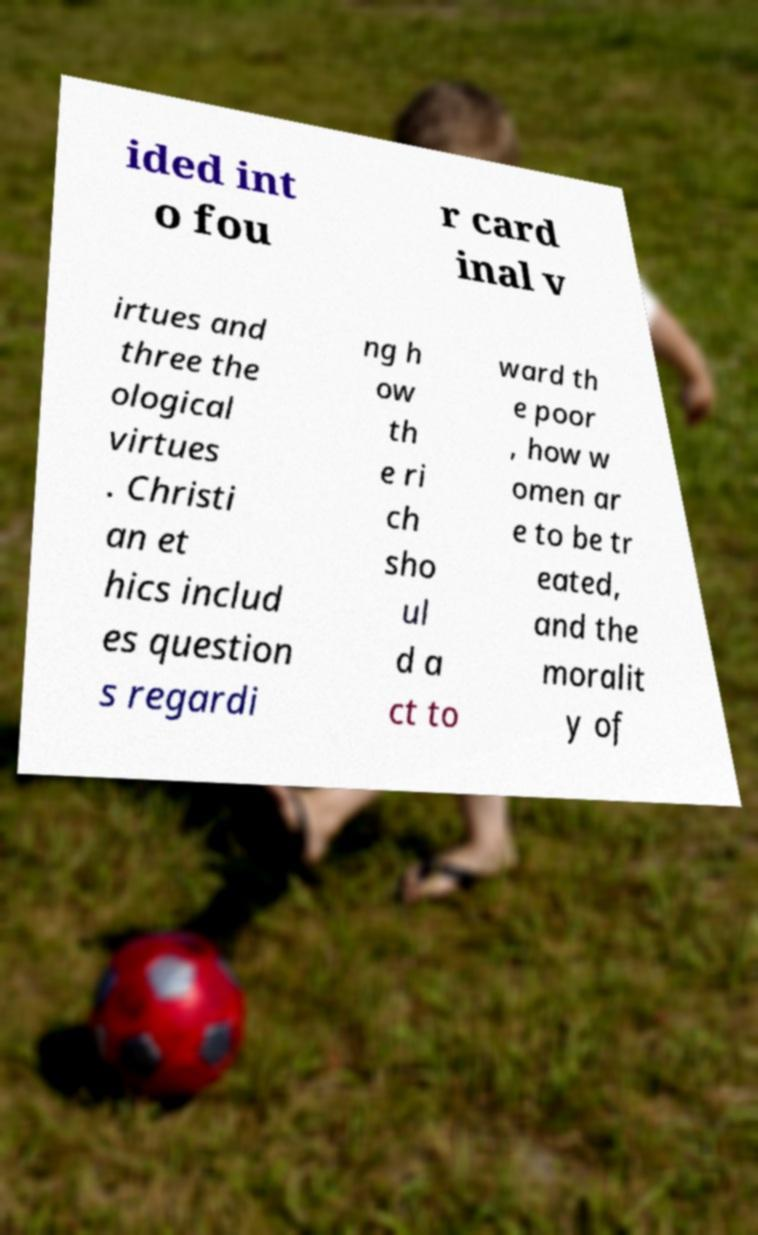I need the written content from this picture converted into text. Can you do that? ided int o fou r card inal v irtues and three the ological virtues . Christi an et hics includ es question s regardi ng h ow th e ri ch sho ul d a ct to ward th e poor , how w omen ar e to be tr eated, and the moralit y of 